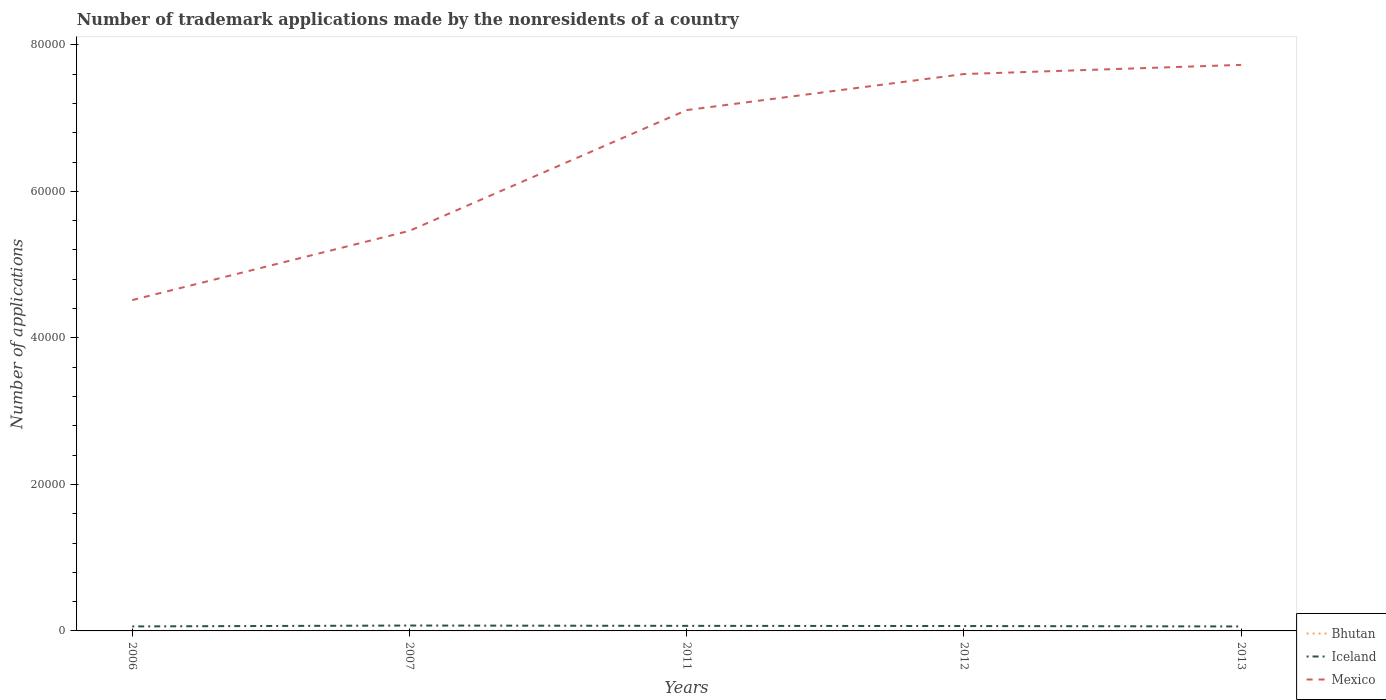Is the number of lines equal to the number of legend labels?
Give a very brief answer. Yes. Across all years, what is the maximum number of trademark applications made by the nonresidents in Mexico?
Your answer should be compact. 4.52e+04. In which year was the number of trademark applications made by the nonresidents in Iceland maximum?
Provide a short and direct response. 2013. What is the total number of trademark applications made by the nonresidents in Mexico in the graph?
Make the answer very short. -1253. What is the difference between the highest and the second highest number of trademark applications made by the nonresidents in Iceland?
Ensure brevity in your answer.  125. Is the number of trademark applications made by the nonresidents in Bhutan strictly greater than the number of trademark applications made by the nonresidents in Mexico over the years?
Offer a terse response. Yes. How many lines are there?
Your response must be concise. 3. Are the values on the major ticks of Y-axis written in scientific E-notation?
Make the answer very short. No. Does the graph contain grids?
Your response must be concise. No. Where does the legend appear in the graph?
Your answer should be compact. Bottom right. How many legend labels are there?
Keep it short and to the point. 3. How are the legend labels stacked?
Ensure brevity in your answer.  Vertical. What is the title of the graph?
Give a very brief answer. Number of trademark applications made by the nonresidents of a country. What is the label or title of the X-axis?
Your answer should be compact. Years. What is the label or title of the Y-axis?
Provide a succinct answer. Number of applications. What is the Number of applications in Iceland in 2006?
Ensure brevity in your answer.  614. What is the Number of applications of Mexico in 2006?
Give a very brief answer. 4.52e+04. What is the Number of applications in Bhutan in 2007?
Offer a terse response. 18. What is the Number of applications in Iceland in 2007?
Offer a terse response. 735. What is the Number of applications of Mexico in 2007?
Make the answer very short. 5.46e+04. What is the Number of applications of Bhutan in 2011?
Provide a succinct answer. 8. What is the Number of applications of Iceland in 2011?
Provide a short and direct response. 691. What is the Number of applications of Mexico in 2011?
Provide a succinct answer. 7.11e+04. What is the Number of applications in Bhutan in 2012?
Your response must be concise. 24. What is the Number of applications of Iceland in 2012?
Your answer should be very brief. 667. What is the Number of applications in Mexico in 2012?
Provide a short and direct response. 7.60e+04. What is the Number of applications in Iceland in 2013?
Offer a very short reply. 610. What is the Number of applications of Mexico in 2013?
Your response must be concise. 7.73e+04. Across all years, what is the maximum Number of applications in Iceland?
Your response must be concise. 735. Across all years, what is the maximum Number of applications of Mexico?
Offer a very short reply. 7.73e+04. Across all years, what is the minimum Number of applications of Bhutan?
Provide a succinct answer. 8. Across all years, what is the minimum Number of applications in Iceland?
Your answer should be very brief. 610. Across all years, what is the minimum Number of applications in Mexico?
Your answer should be compact. 4.52e+04. What is the total Number of applications in Iceland in the graph?
Make the answer very short. 3317. What is the total Number of applications in Mexico in the graph?
Offer a very short reply. 3.24e+05. What is the difference between the Number of applications of Bhutan in 2006 and that in 2007?
Offer a very short reply. -4. What is the difference between the Number of applications in Iceland in 2006 and that in 2007?
Provide a short and direct response. -121. What is the difference between the Number of applications in Mexico in 2006 and that in 2007?
Provide a short and direct response. -9449. What is the difference between the Number of applications in Bhutan in 2006 and that in 2011?
Offer a terse response. 6. What is the difference between the Number of applications of Iceland in 2006 and that in 2011?
Give a very brief answer. -77. What is the difference between the Number of applications in Mexico in 2006 and that in 2011?
Make the answer very short. -2.59e+04. What is the difference between the Number of applications in Iceland in 2006 and that in 2012?
Offer a terse response. -53. What is the difference between the Number of applications of Mexico in 2006 and that in 2012?
Keep it short and to the point. -3.08e+04. What is the difference between the Number of applications of Bhutan in 2006 and that in 2013?
Provide a succinct answer. 1. What is the difference between the Number of applications in Mexico in 2006 and that in 2013?
Offer a terse response. -3.21e+04. What is the difference between the Number of applications in Mexico in 2007 and that in 2011?
Your answer should be compact. -1.65e+04. What is the difference between the Number of applications of Iceland in 2007 and that in 2012?
Make the answer very short. 68. What is the difference between the Number of applications in Mexico in 2007 and that in 2012?
Give a very brief answer. -2.14e+04. What is the difference between the Number of applications of Iceland in 2007 and that in 2013?
Make the answer very short. 125. What is the difference between the Number of applications of Mexico in 2007 and that in 2013?
Your response must be concise. -2.27e+04. What is the difference between the Number of applications of Mexico in 2011 and that in 2012?
Offer a terse response. -4919. What is the difference between the Number of applications in Iceland in 2011 and that in 2013?
Ensure brevity in your answer.  81. What is the difference between the Number of applications in Mexico in 2011 and that in 2013?
Give a very brief answer. -6172. What is the difference between the Number of applications of Iceland in 2012 and that in 2013?
Offer a terse response. 57. What is the difference between the Number of applications in Mexico in 2012 and that in 2013?
Your answer should be compact. -1253. What is the difference between the Number of applications in Bhutan in 2006 and the Number of applications in Iceland in 2007?
Give a very brief answer. -721. What is the difference between the Number of applications in Bhutan in 2006 and the Number of applications in Mexico in 2007?
Keep it short and to the point. -5.46e+04. What is the difference between the Number of applications of Iceland in 2006 and the Number of applications of Mexico in 2007?
Ensure brevity in your answer.  -5.40e+04. What is the difference between the Number of applications in Bhutan in 2006 and the Number of applications in Iceland in 2011?
Your answer should be very brief. -677. What is the difference between the Number of applications in Bhutan in 2006 and the Number of applications in Mexico in 2011?
Your response must be concise. -7.11e+04. What is the difference between the Number of applications of Iceland in 2006 and the Number of applications of Mexico in 2011?
Your answer should be compact. -7.05e+04. What is the difference between the Number of applications of Bhutan in 2006 and the Number of applications of Iceland in 2012?
Provide a short and direct response. -653. What is the difference between the Number of applications of Bhutan in 2006 and the Number of applications of Mexico in 2012?
Give a very brief answer. -7.60e+04. What is the difference between the Number of applications of Iceland in 2006 and the Number of applications of Mexico in 2012?
Keep it short and to the point. -7.54e+04. What is the difference between the Number of applications of Bhutan in 2006 and the Number of applications of Iceland in 2013?
Offer a very short reply. -596. What is the difference between the Number of applications in Bhutan in 2006 and the Number of applications in Mexico in 2013?
Your answer should be compact. -7.72e+04. What is the difference between the Number of applications of Iceland in 2006 and the Number of applications of Mexico in 2013?
Ensure brevity in your answer.  -7.66e+04. What is the difference between the Number of applications in Bhutan in 2007 and the Number of applications in Iceland in 2011?
Make the answer very short. -673. What is the difference between the Number of applications in Bhutan in 2007 and the Number of applications in Mexico in 2011?
Provide a succinct answer. -7.11e+04. What is the difference between the Number of applications of Iceland in 2007 and the Number of applications of Mexico in 2011?
Provide a succinct answer. -7.04e+04. What is the difference between the Number of applications of Bhutan in 2007 and the Number of applications of Iceland in 2012?
Your answer should be very brief. -649. What is the difference between the Number of applications of Bhutan in 2007 and the Number of applications of Mexico in 2012?
Provide a succinct answer. -7.60e+04. What is the difference between the Number of applications in Iceland in 2007 and the Number of applications in Mexico in 2012?
Keep it short and to the point. -7.53e+04. What is the difference between the Number of applications of Bhutan in 2007 and the Number of applications of Iceland in 2013?
Your answer should be very brief. -592. What is the difference between the Number of applications in Bhutan in 2007 and the Number of applications in Mexico in 2013?
Your answer should be compact. -7.72e+04. What is the difference between the Number of applications in Iceland in 2007 and the Number of applications in Mexico in 2013?
Your answer should be very brief. -7.65e+04. What is the difference between the Number of applications in Bhutan in 2011 and the Number of applications in Iceland in 2012?
Provide a succinct answer. -659. What is the difference between the Number of applications of Bhutan in 2011 and the Number of applications of Mexico in 2012?
Your answer should be compact. -7.60e+04. What is the difference between the Number of applications of Iceland in 2011 and the Number of applications of Mexico in 2012?
Provide a short and direct response. -7.53e+04. What is the difference between the Number of applications of Bhutan in 2011 and the Number of applications of Iceland in 2013?
Provide a short and direct response. -602. What is the difference between the Number of applications in Bhutan in 2011 and the Number of applications in Mexico in 2013?
Give a very brief answer. -7.73e+04. What is the difference between the Number of applications in Iceland in 2011 and the Number of applications in Mexico in 2013?
Provide a succinct answer. -7.66e+04. What is the difference between the Number of applications of Bhutan in 2012 and the Number of applications of Iceland in 2013?
Provide a succinct answer. -586. What is the difference between the Number of applications in Bhutan in 2012 and the Number of applications in Mexico in 2013?
Give a very brief answer. -7.72e+04. What is the difference between the Number of applications of Iceland in 2012 and the Number of applications of Mexico in 2013?
Make the answer very short. -7.66e+04. What is the average Number of applications in Bhutan per year?
Your answer should be compact. 15.4. What is the average Number of applications in Iceland per year?
Provide a succinct answer. 663.4. What is the average Number of applications in Mexico per year?
Keep it short and to the point. 6.48e+04. In the year 2006, what is the difference between the Number of applications of Bhutan and Number of applications of Iceland?
Offer a terse response. -600. In the year 2006, what is the difference between the Number of applications in Bhutan and Number of applications in Mexico?
Make the answer very short. -4.51e+04. In the year 2006, what is the difference between the Number of applications in Iceland and Number of applications in Mexico?
Your answer should be compact. -4.45e+04. In the year 2007, what is the difference between the Number of applications in Bhutan and Number of applications in Iceland?
Provide a succinct answer. -717. In the year 2007, what is the difference between the Number of applications in Bhutan and Number of applications in Mexico?
Offer a terse response. -5.46e+04. In the year 2007, what is the difference between the Number of applications in Iceland and Number of applications in Mexico?
Keep it short and to the point. -5.39e+04. In the year 2011, what is the difference between the Number of applications in Bhutan and Number of applications in Iceland?
Ensure brevity in your answer.  -683. In the year 2011, what is the difference between the Number of applications in Bhutan and Number of applications in Mexico?
Your answer should be compact. -7.11e+04. In the year 2011, what is the difference between the Number of applications in Iceland and Number of applications in Mexico?
Offer a very short reply. -7.04e+04. In the year 2012, what is the difference between the Number of applications of Bhutan and Number of applications of Iceland?
Make the answer very short. -643. In the year 2012, what is the difference between the Number of applications of Bhutan and Number of applications of Mexico?
Give a very brief answer. -7.60e+04. In the year 2012, what is the difference between the Number of applications in Iceland and Number of applications in Mexico?
Provide a short and direct response. -7.53e+04. In the year 2013, what is the difference between the Number of applications in Bhutan and Number of applications in Iceland?
Offer a very short reply. -597. In the year 2013, what is the difference between the Number of applications in Bhutan and Number of applications in Mexico?
Give a very brief answer. -7.72e+04. In the year 2013, what is the difference between the Number of applications of Iceland and Number of applications of Mexico?
Provide a succinct answer. -7.67e+04. What is the ratio of the Number of applications of Bhutan in 2006 to that in 2007?
Offer a terse response. 0.78. What is the ratio of the Number of applications of Iceland in 2006 to that in 2007?
Provide a succinct answer. 0.84. What is the ratio of the Number of applications of Mexico in 2006 to that in 2007?
Provide a short and direct response. 0.83. What is the ratio of the Number of applications of Bhutan in 2006 to that in 2011?
Provide a short and direct response. 1.75. What is the ratio of the Number of applications of Iceland in 2006 to that in 2011?
Provide a succinct answer. 0.89. What is the ratio of the Number of applications in Mexico in 2006 to that in 2011?
Keep it short and to the point. 0.64. What is the ratio of the Number of applications of Bhutan in 2006 to that in 2012?
Make the answer very short. 0.58. What is the ratio of the Number of applications in Iceland in 2006 to that in 2012?
Your response must be concise. 0.92. What is the ratio of the Number of applications in Mexico in 2006 to that in 2012?
Ensure brevity in your answer.  0.59. What is the ratio of the Number of applications in Iceland in 2006 to that in 2013?
Make the answer very short. 1.01. What is the ratio of the Number of applications of Mexico in 2006 to that in 2013?
Provide a short and direct response. 0.58. What is the ratio of the Number of applications in Bhutan in 2007 to that in 2011?
Make the answer very short. 2.25. What is the ratio of the Number of applications in Iceland in 2007 to that in 2011?
Your response must be concise. 1.06. What is the ratio of the Number of applications of Mexico in 2007 to that in 2011?
Make the answer very short. 0.77. What is the ratio of the Number of applications of Bhutan in 2007 to that in 2012?
Your response must be concise. 0.75. What is the ratio of the Number of applications in Iceland in 2007 to that in 2012?
Offer a terse response. 1.1. What is the ratio of the Number of applications in Mexico in 2007 to that in 2012?
Provide a short and direct response. 0.72. What is the ratio of the Number of applications in Bhutan in 2007 to that in 2013?
Provide a short and direct response. 1.38. What is the ratio of the Number of applications of Iceland in 2007 to that in 2013?
Give a very brief answer. 1.2. What is the ratio of the Number of applications in Mexico in 2007 to that in 2013?
Give a very brief answer. 0.71. What is the ratio of the Number of applications of Bhutan in 2011 to that in 2012?
Offer a terse response. 0.33. What is the ratio of the Number of applications in Iceland in 2011 to that in 2012?
Provide a succinct answer. 1.04. What is the ratio of the Number of applications in Mexico in 2011 to that in 2012?
Offer a terse response. 0.94. What is the ratio of the Number of applications in Bhutan in 2011 to that in 2013?
Your answer should be compact. 0.62. What is the ratio of the Number of applications of Iceland in 2011 to that in 2013?
Your answer should be very brief. 1.13. What is the ratio of the Number of applications in Mexico in 2011 to that in 2013?
Offer a terse response. 0.92. What is the ratio of the Number of applications in Bhutan in 2012 to that in 2013?
Offer a terse response. 1.85. What is the ratio of the Number of applications of Iceland in 2012 to that in 2013?
Keep it short and to the point. 1.09. What is the ratio of the Number of applications in Mexico in 2012 to that in 2013?
Give a very brief answer. 0.98. What is the difference between the highest and the second highest Number of applications of Bhutan?
Give a very brief answer. 6. What is the difference between the highest and the second highest Number of applications in Mexico?
Your response must be concise. 1253. What is the difference between the highest and the lowest Number of applications of Bhutan?
Make the answer very short. 16. What is the difference between the highest and the lowest Number of applications in Iceland?
Provide a succinct answer. 125. What is the difference between the highest and the lowest Number of applications of Mexico?
Your answer should be compact. 3.21e+04. 